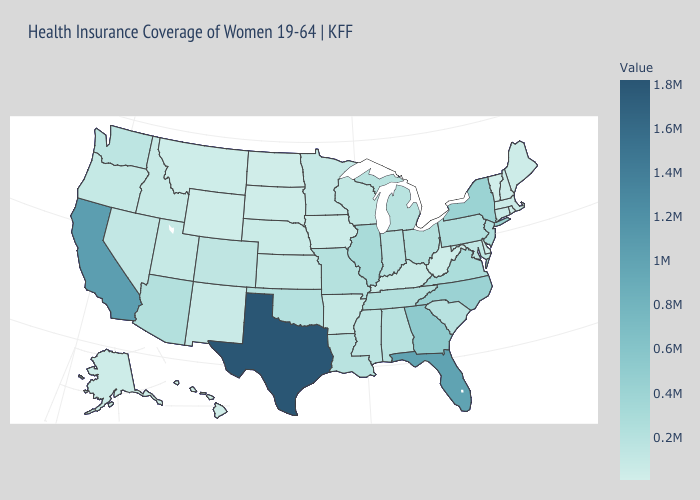Among the states that border Connecticut , which have the lowest value?
Give a very brief answer. Rhode Island. Which states hav the highest value in the South?
Keep it brief. Texas. Which states have the lowest value in the MidWest?
Write a very short answer. North Dakota. Does the map have missing data?
Answer briefly. No. Among the states that border Louisiana , does Arkansas have the lowest value?
Give a very brief answer. Yes. Does Massachusetts have a higher value than Florida?
Answer briefly. No. Does Montana have the highest value in the USA?
Concise answer only. No. 